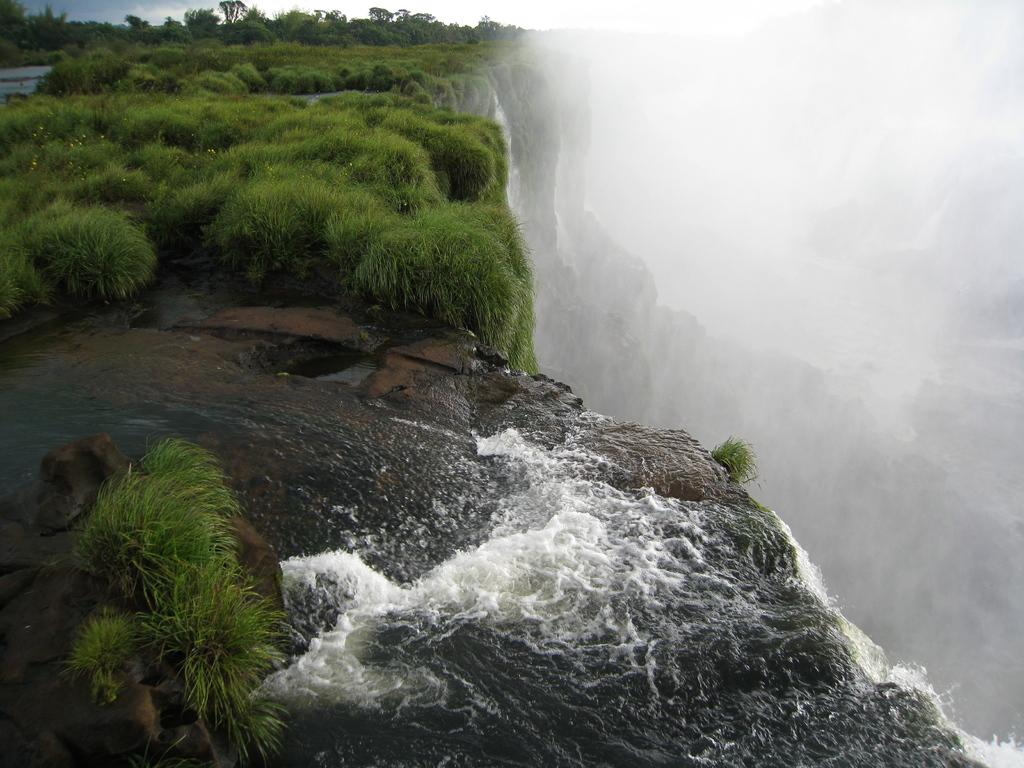What is in the foreground of the image? There are rocks, grass, and water in the foreground of the image. What natural feature can be seen on the right side of the image? There is a waterfall on the right side of the image. Where does the waterfall originate from? The waterfall originates from a cliff. What type of vegetation is present on the cliff? There is grass on the cliff. What is visible at the top of the image? The sky is visible at the top of the image. Can you see a pickle on the cliff in the image? There is no pickle present in the image. What type of bedroom can be seen in the image? There is no bedroom present in the image; it features a waterfall, cliff, and natural surroundings. 